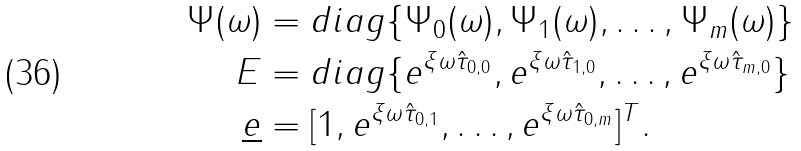<formula> <loc_0><loc_0><loc_500><loc_500>\Psi ( \omega ) & = d i a g \{ \Psi _ { 0 } ( \omega ) , \Psi _ { 1 } ( \omega ) , \dots , \Psi _ { m } ( \omega ) \} \\ E & = d i a g \{ e ^ { \xi \omega \hat { \tau } _ { 0 , 0 } } , e ^ { \xi \omega \hat { \tau } _ { 1 , 0 } } , \dots , e ^ { \xi \omega \hat { \tau } _ { m , 0 } } \} \\ \underline { e } & = [ 1 , e ^ { \xi \omega \hat { \tau } _ { 0 , 1 } } , \dots , e ^ { \xi \omega \hat { \tau } _ { 0 , m } } ] ^ { T } .</formula> 